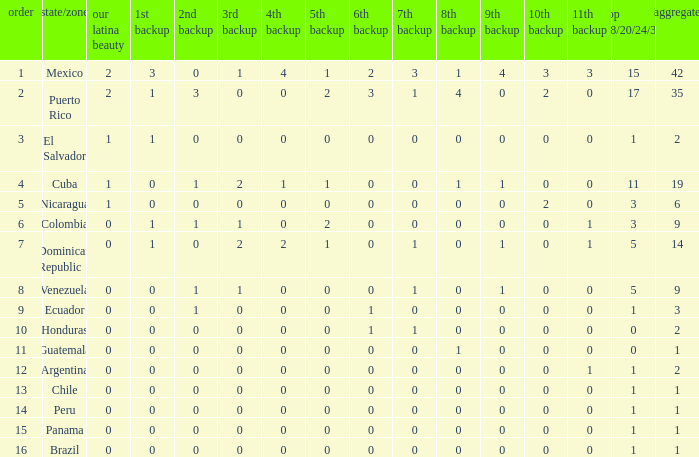What is the total number of 3rd runners-up of the country ranked lower than 12 with a 10th runner-up of 0, an 8th runner-up less than 1, and a 7th runner-up of 0? 4.0. 